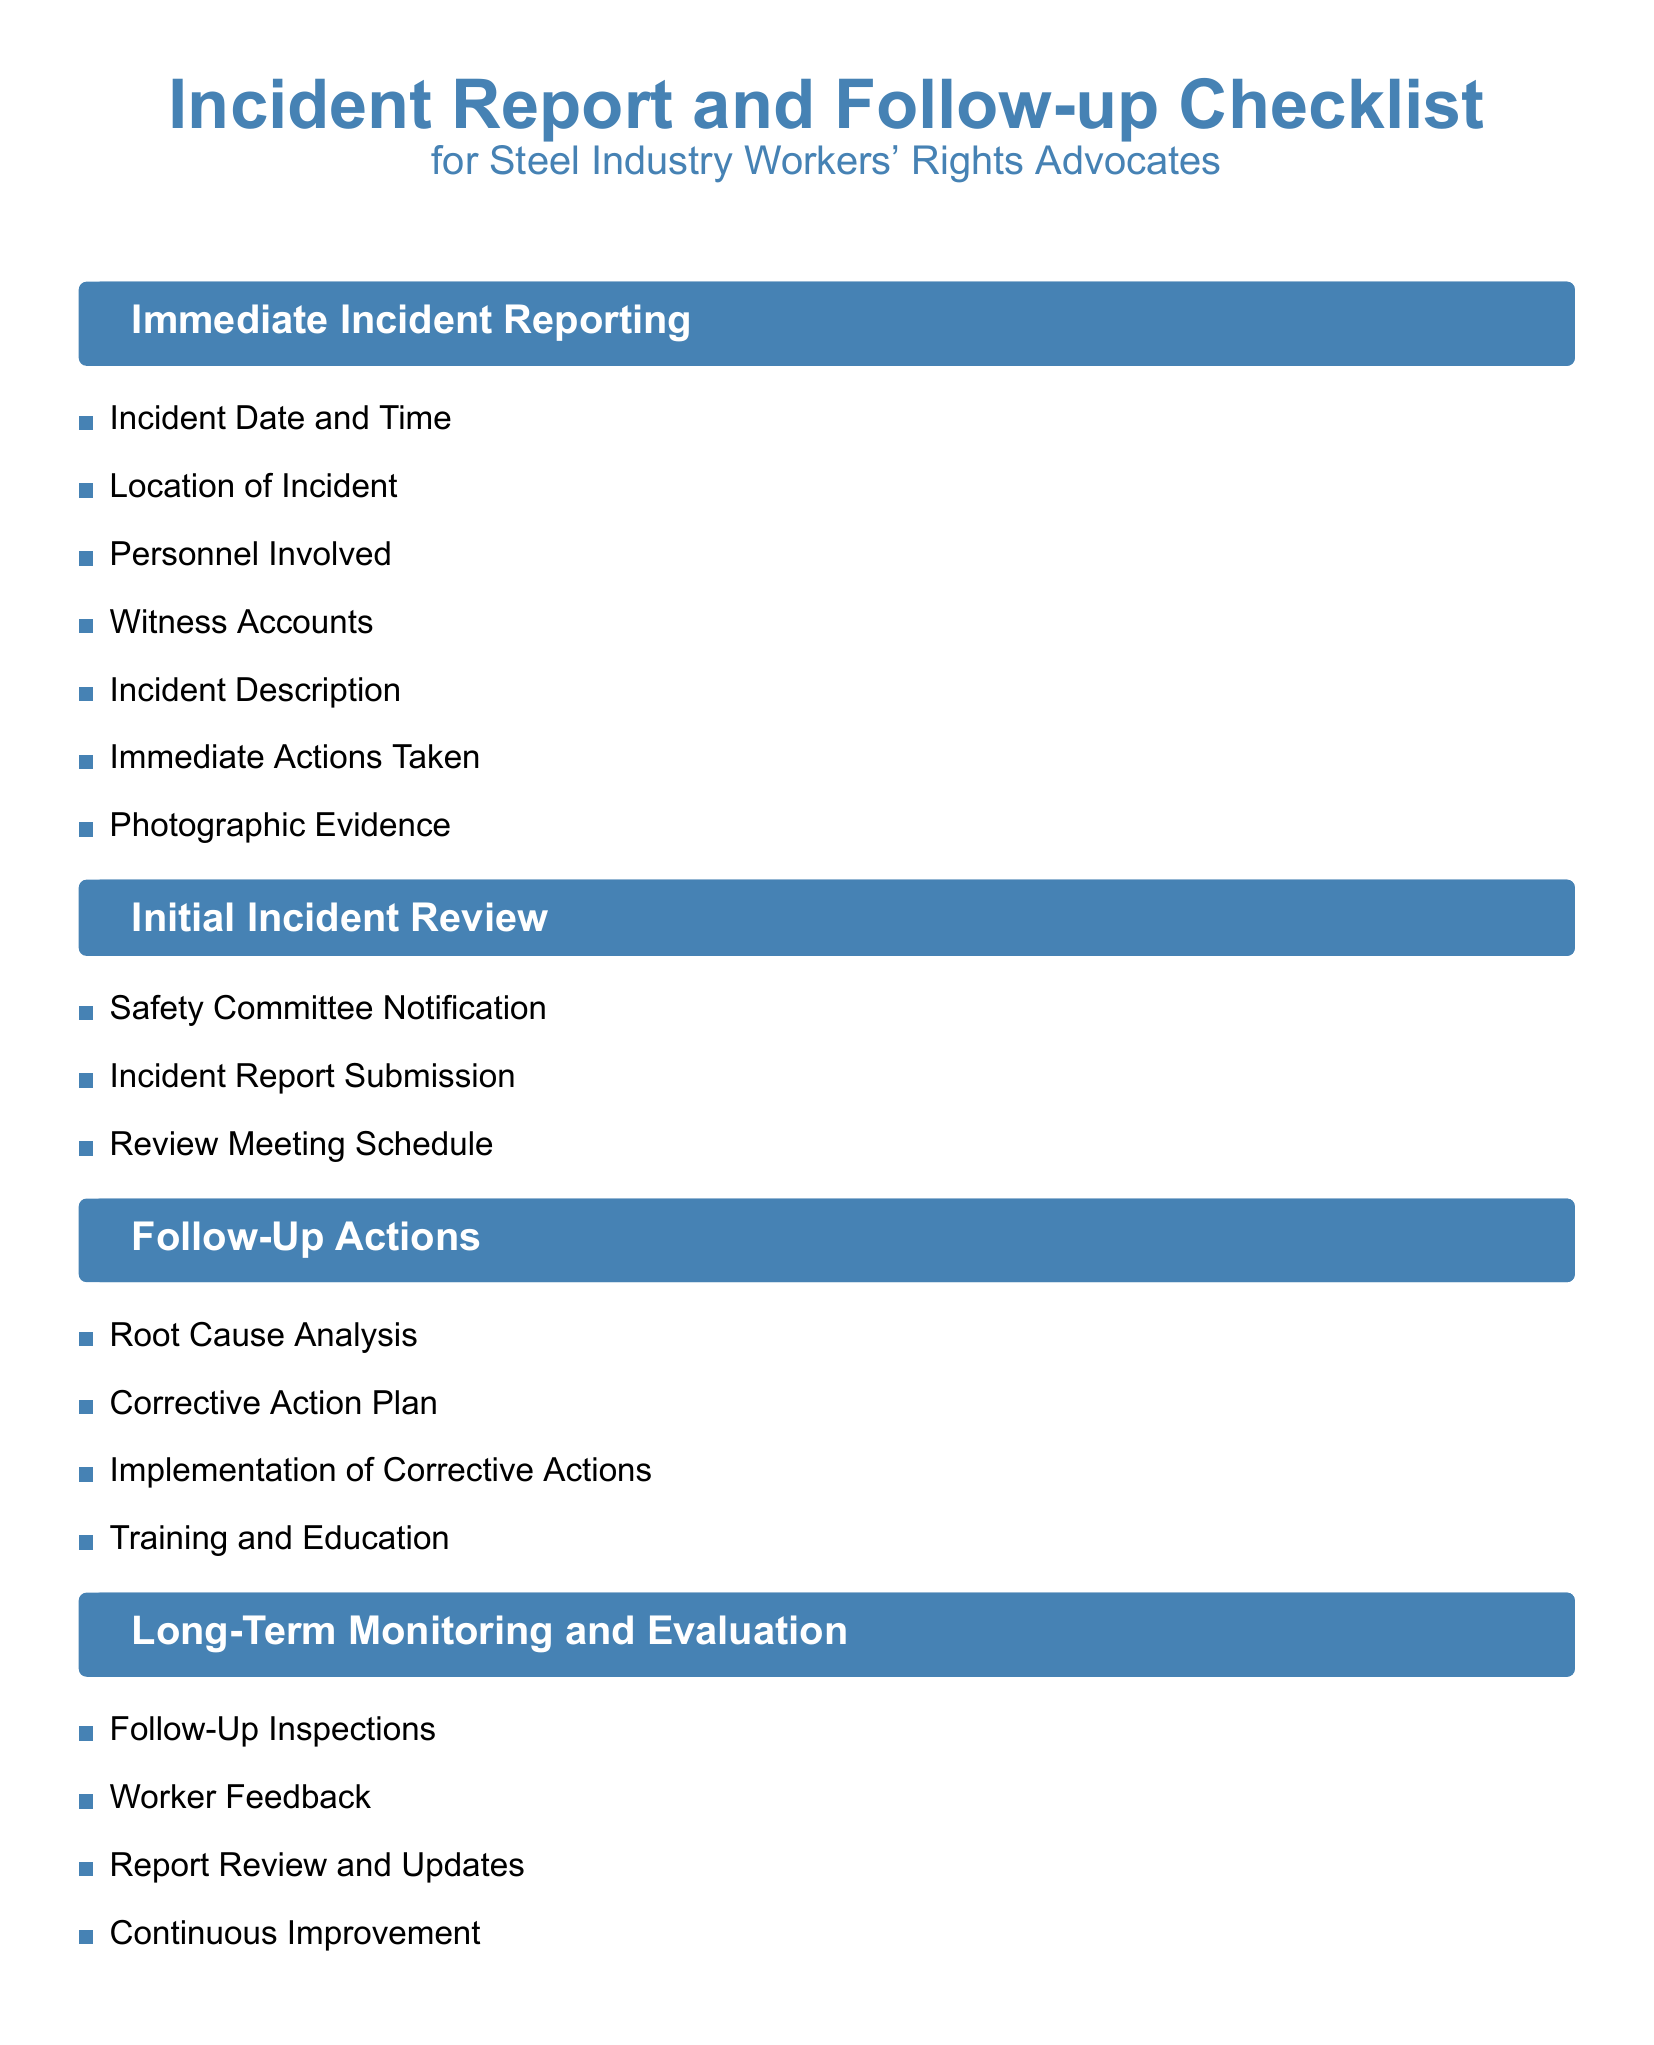What is the checklist title? The checklist title is prominently displayed at the beginning of the document, identifying the document as related to "Incident Report and Follow-up".
Answer: Incident Report and Follow-up Checklist How many sections are in the checklist? The document is divided into four distinct sections: Immediate Incident Reporting, Initial Incident Review, Follow-Up Actions, and Long-Term Monitoring and Evaluation.
Answer: Four What should be included in the Immediate Incident Reporting section? This section lists specific items that need to be documented immediately after an incident, including location, personnel involved, and witness accounts among others.
Answer: Incident Date and Time, Location of Incident, Personnel Involved, Witness Accounts, Incident Description, Immediate Actions Taken, Photographic Evidence What is the first item in the Follow-Up Actions section? The first item listed in the Follow-Up Actions section is identified as the starting point for addressing the incident through further analysis.
Answer: Root Cause Analysis What type of feedback is mentioned in the Long-Term Monitoring and Evaluation section? This section emphasizes the importance of input from workers regarding their experiences and perspectives after an incident, contributing to ongoing safety improvements.
Answer: Worker Feedback 